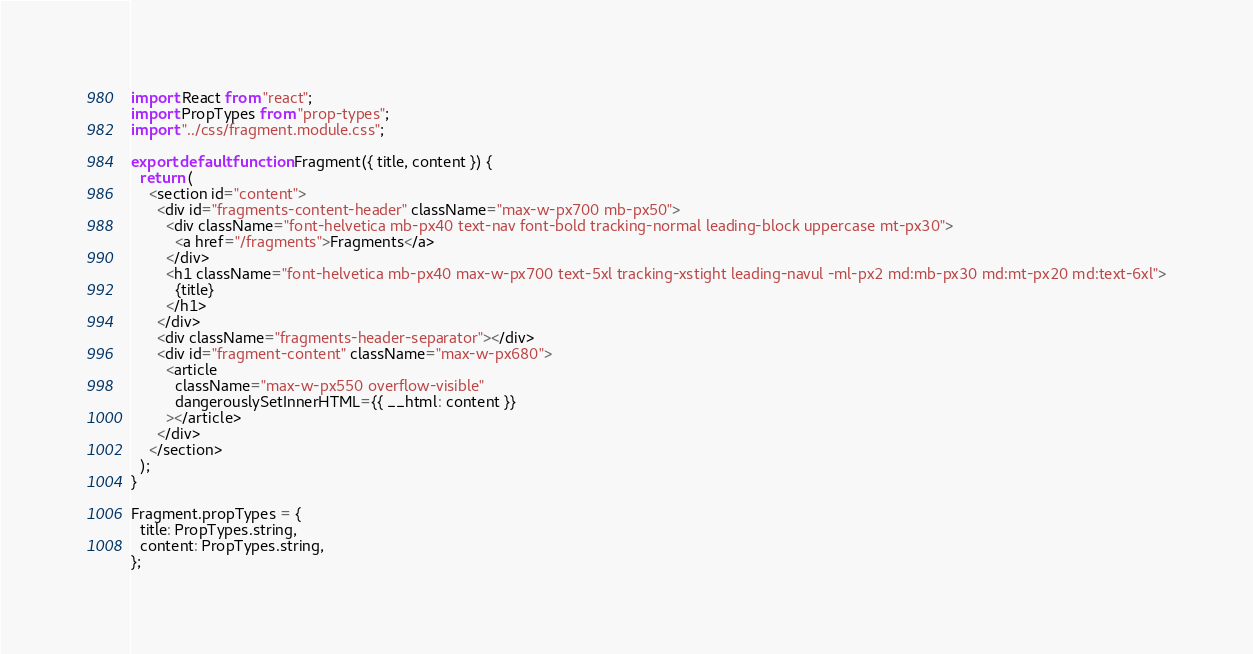Convert code to text. <code><loc_0><loc_0><loc_500><loc_500><_JavaScript_>import React from "react";
import PropTypes from "prop-types";
import "../css/fragment.module.css";

export default function Fragment({ title, content }) {
  return (
    <section id="content">
      <div id="fragments-content-header" className="max-w-px700 mb-px50">
        <div className="font-helvetica mb-px40 text-nav font-bold tracking-normal leading-block uppercase mt-px30">
          <a href="/fragments">Fragments</a>
        </div>
        <h1 className="font-helvetica mb-px40 max-w-px700 text-5xl tracking-xstight leading-navul -ml-px2 md:mb-px30 md:mt-px20 md:text-6xl">
          {title}
        </h1>
      </div>
      <div className="fragments-header-separator"></div>
      <div id="fragment-content" className="max-w-px680">
        <article
          className="max-w-px550 overflow-visible"
          dangerouslySetInnerHTML={{ __html: content }}
        ></article>
      </div>
    </section>
  );
}

Fragment.propTypes = {
  title: PropTypes.string,
  content: PropTypes.string,
};
</code> 